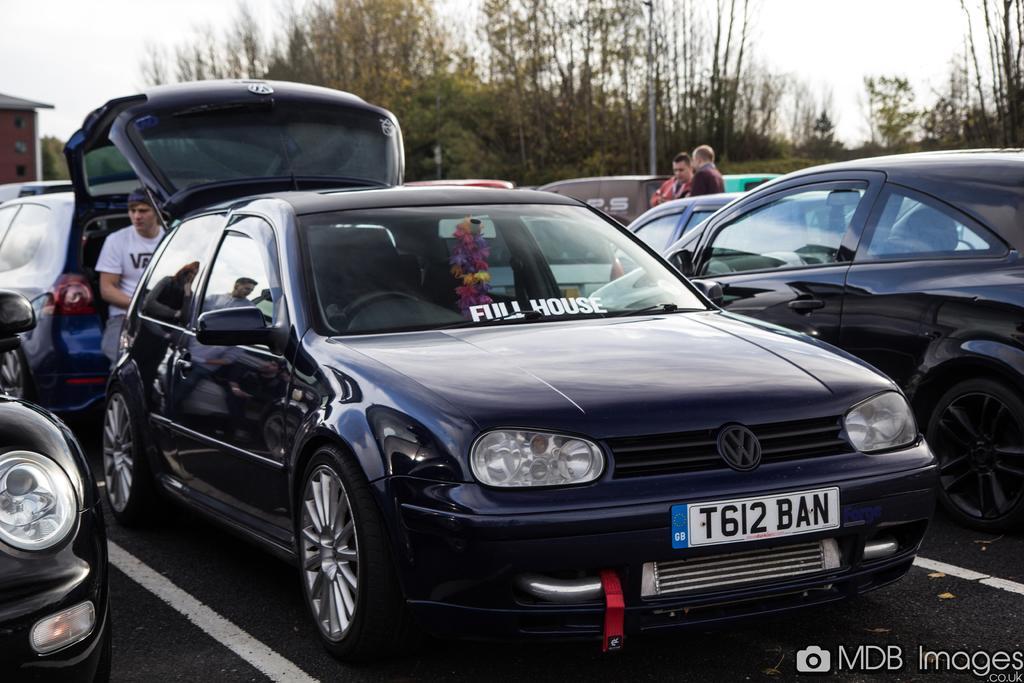Please provide a concise description of this image. In this picture there are vehicles, there are persons standing and there is a person sitting. In the background there are trees and there is a house and the sky is cloudy. 